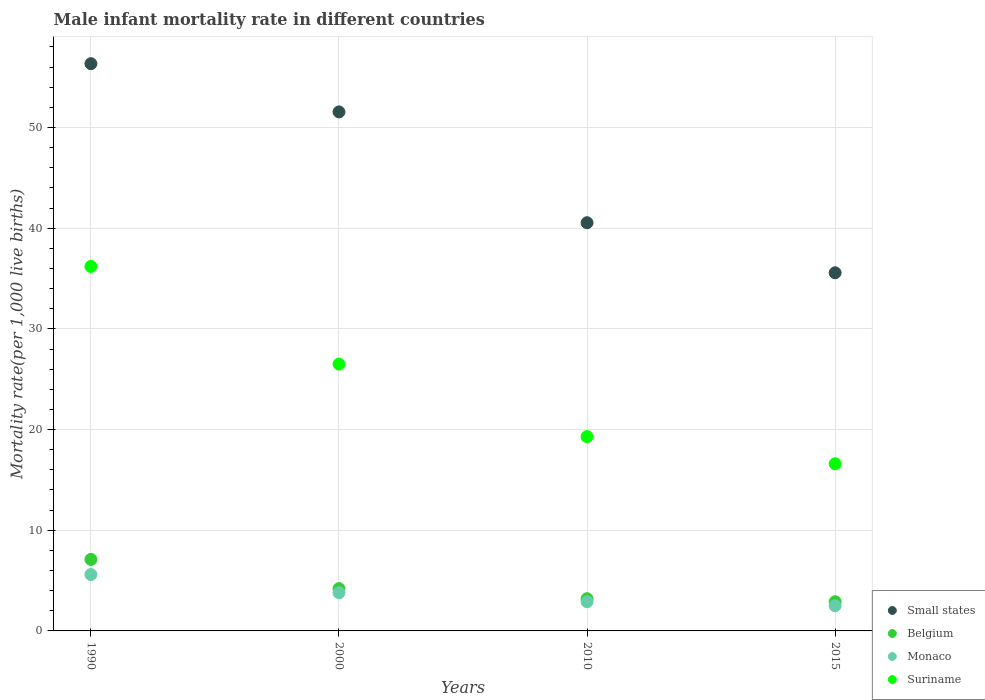How many different coloured dotlines are there?
Your answer should be compact. 4. What is the male infant mortality rate in Suriname in 2010?
Make the answer very short. 19.3. Across all years, what is the maximum male infant mortality rate in Small states?
Keep it short and to the point. 56.34. In which year was the male infant mortality rate in Monaco minimum?
Offer a terse response. 2015. What is the total male infant mortality rate in Suriname in the graph?
Your answer should be very brief. 98.6. What is the difference between the male infant mortality rate in Small states in 2000 and that in 2015?
Offer a terse response. 15.98. What is the difference between the male infant mortality rate in Suriname in 2000 and the male infant mortality rate in Belgium in 2010?
Your answer should be very brief. 23.3. What is the average male infant mortality rate in Belgium per year?
Ensure brevity in your answer.  4.35. In the year 2010, what is the difference between the male infant mortality rate in Suriname and male infant mortality rate in Monaco?
Give a very brief answer. 16.4. In how many years, is the male infant mortality rate in Monaco greater than 50?
Make the answer very short. 0. What is the ratio of the male infant mortality rate in Small states in 1990 to that in 2010?
Make the answer very short. 1.39. What is the difference between the highest and the second highest male infant mortality rate in Monaco?
Your answer should be very brief. 1.8. What is the difference between the highest and the lowest male infant mortality rate in Small states?
Ensure brevity in your answer.  20.77. Is it the case that in every year, the sum of the male infant mortality rate in Suriname and male infant mortality rate in Monaco  is greater than the sum of male infant mortality rate in Belgium and male infant mortality rate in Small states?
Your answer should be compact. Yes. Is it the case that in every year, the sum of the male infant mortality rate in Suriname and male infant mortality rate in Belgium  is greater than the male infant mortality rate in Monaco?
Offer a terse response. Yes. Is the male infant mortality rate in Belgium strictly greater than the male infant mortality rate in Small states over the years?
Offer a very short reply. No. How many dotlines are there?
Keep it short and to the point. 4. Are the values on the major ticks of Y-axis written in scientific E-notation?
Make the answer very short. No. Does the graph contain any zero values?
Your answer should be very brief. No. Does the graph contain grids?
Provide a succinct answer. Yes. Where does the legend appear in the graph?
Offer a very short reply. Bottom right. How many legend labels are there?
Keep it short and to the point. 4. What is the title of the graph?
Your answer should be compact. Male infant mortality rate in different countries. What is the label or title of the X-axis?
Keep it short and to the point. Years. What is the label or title of the Y-axis?
Provide a succinct answer. Mortality rate(per 1,0 live births). What is the Mortality rate(per 1,000 live births) in Small states in 1990?
Offer a very short reply. 56.34. What is the Mortality rate(per 1,000 live births) of Suriname in 1990?
Your response must be concise. 36.2. What is the Mortality rate(per 1,000 live births) in Small states in 2000?
Your response must be concise. 51.55. What is the Mortality rate(per 1,000 live births) of Belgium in 2000?
Keep it short and to the point. 4.2. What is the Mortality rate(per 1,000 live births) of Monaco in 2000?
Give a very brief answer. 3.8. What is the Mortality rate(per 1,000 live births) in Suriname in 2000?
Your answer should be very brief. 26.5. What is the Mortality rate(per 1,000 live births) of Small states in 2010?
Keep it short and to the point. 40.54. What is the Mortality rate(per 1,000 live births) in Belgium in 2010?
Your answer should be very brief. 3.2. What is the Mortality rate(per 1,000 live births) in Monaco in 2010?
Give a very brief answer. 2.9. What is the Mortality rate(per 1,000 live births) of Suriname in 2010?
Offer a very short reply. 19.3. What is the Mortality rate(per 1,000 live births) of Small states in 2015?
Ensure brevity in your answer.  35.57. What is the Mortality rate(per 1,000 live births) of Monaco in 2015?
Ensure brevity in your answer.  2.5. What is the Mortality rate(per 1,000 live births) in Suriname in 2015?
Ensure brevity in your answer.  16.6. Across all years, what is the maximum Mortality rate(per 1,000 live births) in Small states?
Provide a succinct answer. 56.34. Across all years, what is the maximum Mortality rate(per 1,000 live births) in Monaco?
Offer a very short reply. 5.6. Across all years, what is the maximum Mortality rate(per 1,000 live births) of Suriname?
Provide a short and direct response. 36.2. Across all years, what is the minimum Mortality rate(per 1,000 live births) of Small states?
Offer a very short reply. 35.57. Across all years, what is the minimum Mortality rate(per 1,000 live births) in Monaco?
Provide a short and direct response. 2.5. What is the total Mortality rate(per 1,000 live births) of Small states in the graph?
Your answer should be compact. 184. What is the total Mortality rate(per 1,000 live births) in Suriname in the graph?
Ensure brevity in your answer.  98.6. What is the difference between the Mortality rate(per 1,000 live births) of Small states in 1990 and that in 2000?
Your answer should be very brief. 4.79. What is the difference between the Mortality rate(per 1,000 live births) in Suriname in 1990 and that in 2000?
Make the answer very short. 9.7. What is the difference between the Mortality rate(per 1,000 live births) of Small states in 1990 and that in 2010?
Provide a short and direct response. 15.8. What is the difference between the Mortality rate(per 1,000 live births) of Belgium in 1990 and that in 2010?
Provide a succinct answer. 3.9. What is the difference between the Mortality rate(per 1,000 live births) in Small states in 1990 and that in 2015?
Your answer should be very brief. 20.77. What is the difference between the Mortality rate(per 1,000 live births) of Belgium in 1990 and that in 2015?
Provide a short and direct response. 4.2. What is the difference between the Mortality rate(per 1,000 live births) of Monaco in 1990 and that in 2015?
Keep it short and to the point. 3.1. What is the difference between the Mortality rate(per 1,000 live births) in Suriname in 1990 and that in 2015?
Give a very brief answer. 19.6. What is the difference between the Mortality rate(per 1,000 live births) in Small states in 2000 and that in 2010?
Your answer should be very brief. 11.01. What is the difference between the Mortality rate(per 1,000 live births) of Small states in 2000 and that in 2015?
Make the answer very short. 15.98. What is the difference between the Mortality rate(per 1,000 live births) in Suriname in 2000 and that in 2015?
Offer a very short reply. 9.9. What is the difference between the Mortality rate(per 1,000 live births) of Small states in 2010 and that in 2015?
Keep it short and to the point. 4.97. What is the difference between the Mortality rate(per 1,000 live births) in Belgium in 2010 and that in 2015?
Provide a succinct answer. 0.3. What is the difference between the Mortality rate(per 1,000 live births) in Small states in 1990 and the Mortality rate(per 1,000 live births) in Belgium in 2000?
Make the answer very short. 52.14. What is the difference between the Mortality rate(per 1,000 live births) in Small states in 1990 and the Mortality rate(per 1,000 live births) in Monaco in 2000?
Your response must be concise. 52.54. What is the difference between the Mortality rate(per 1,000 live births) in Small states in 1990 and the Mortality rate(per 1,000 live births) in Suriname in 2000?
Your answer should be very brief. 29.84. What is the difference between the Mortality rate(per 1,000 live births) of Belgium in 1990 and the Mortality rate(per 1,000 live births) of Monaco in 2000?
Provide a short and direct response. 3.3. What is the difference between the Mortality rate(per 1,000 live births) of Belgium in 1990 and the Mortality rate(per 1,000 live births) of Suriname in 2000?
Provide a succinct answer. -19.4. What is the difference between the Mortality rate(per 1,000 live births) in Monaco in 1990 and the Mortality rate(per 1,000 live births) in Suriname in 2000?
Keep it short and to the point. -20.9. What is the difference between the Mortality rate(per 1,000 live births) in Small states in 1990 and the Mortality rate(per 1,000 live births) in Belgium in 2010?
Offer a terse response. 53.14. What is the difference between the Mortality rate(per 1,000 live births) in Small states in 1990 and the Mortality rate(per 1,000 live births) in Monaco in 2010?
Offer a very short reply. 53.44. What is the difference between the Mortality rate(per 1,000 live births) in Small states in 1990 and the Mortality rate(per 1,000 live births) in Suriname in 2010?
Offer a very short reply. 37.04. What is the difference between the Mortality rate(per 1,000 live births) in Belgium in 1990 and the Mortality rate(per 1,000 live births) in Monaco in 2010?
Make the answer very short. 4.2. What is the difference between the Mortality rate(per 1,000 live births) in Belgium in 1990 and the Mortality rate(per 1,000 live births) in Suriname in 2010?
Make the answer very short. -12.2. What is the difference between the Mortality rate(per 1,000 live births) of Monaco in 1990 and the Mortality rate(per 1,000 live births) of Suriname in 2010?
Your answer should be very brief. -13.7. What is the difference between the Mortality rate(per 1,000 live births) of Small states in 1990 and the Mortality rate(per 1,000 live births) of Belgium in 2015?
Offer a very short reply. 53.44. What is the difference between the Mortality rate(per 1,000 live births) in Small states in 1990 and the Mortality rate(per 1,000 live births) in Monaco in 2015?
Provide a succinct answer. 53.84. What is the difference between the Mortality rate(per 1,000 live births) of Small states in 1990 and the Mortality rate(per 1,000 live births) of Suriname in 2015?
Your response must be concise. 39.74. What is the difference between the Mortality rate(per 1,000 live births) in Belgium in 1990 and the Mortality rate(per 1,000 live births) in Monaco in 2015?
Your answer should be compact. 4.6. What is the difference between the Mortality rate(per 1,000 live births) of Belgium in 1990 and the Mortality rate(per 1,000 live births) of Suriname in 2015?
Ensure brevity in your answer.  -9.5. What is the difference between the Mortality rate(per 1,000 live births) of Small states in 2000 and the Mortality rate(per 1,000 live births) of Belgium in 2010?
Your response must be concise. 48.35. What is the difference between the Mortality rate(per 1,000 live births) in Small states in 2000 and the Mortality rate(per 1,000 live births) in Monaco in 2010?
Keep it short and to the point. 48.65. What is the difference between the Mortality rate(per 1,000 live births) of Small states in 2000 and the Mortality rate(per 1,000 live births) of Suriname in 2010?
Your answer should be very brief. 32.25. What is the difference between the Mortality rate(per 1,000 live births) of Belgium in 2000 and the Mortality rate(per 1,000 live births) of Monaco in 2010?
Your response must be concise. 1.3. What is the difference between the Mortality rate(per 1,000 live births) in Belgium in 2000 and the Mortality rate(per 1,000 live births) in Suriname in 2010?
Provide a short and direct response. -15.1. What is the difference between the Mortality rate(per 1,000 live births) of Monaco in 2000 and the Mortality rate(per 1,000 live births) of Suriname in 2010?
Make the answer very short. -15.5. What is the difference between the Mortality rate(per 1,000 live births) of Small states in 2000 and the Mortality rate(per 1,000 live births) of Belgium in 2015?
Ensure brevity in your answer.  48.65. What is the difference between the Mortality rate(per 1,000 live births) of Small states in 2000 and the Mortality rate(per 1,000 live births) of Monaco in 2015?
Your answer should be very brief. 49.05. What is the difference between the Mortality rate(per 1,000 live births) of Small states in 2000 and the Mortality rate(per 1,000 live births) of Suriname in 2015?
Offer a very short reply. 34.95. What is the difference between the Mortality rate(per 1,000 live births) of Belgium in 2000 and the Mortality rate(per 1,000 live births) of Monaco in 2015?
Make the answer very short. 1.7. What is the difference between the Mortality rate(per 1,000 live births) in Monaco in 2000 and the Mortality rate(per 1,000 live births) in Suriname in 2015?
Ensure brevity in your answer.  -12.8. What is the difference between the Mortality rate(per 1,000 live births) in Small states in 2010 and the Mortality rate(per 1,000 live births) in Belgium in 2015?
Give a very brief answer. 37.64. What is the difference between the Mortality rate(per 1,000 live births) in Small states in 2010 and the Mortality rate(per 1,000 live births) in Monaco in 2015?
Your answer should be compact. 38.04. What is the difference between the Mortality rate(per 1,000 live births) of Small states in 2010 and the Mortality rate(per 1,000 live births) of Suriname in 2015?
Give a very brief answer. 23.94. What is the difference between the Mortality rate(per 1,000 live births) of Belgium in 2010 and the Mortality rate(per 1,000 live births) of Monaco in 2015?
Keep it short and to the point. 0.7. What is the difference between the Mortality rate(per 1,000 live births) of Monaco in 2010 and the Mortality rate(per 1,000 live births) of Suriname in 2015?
Make the answer very short. -13.7. What is the average Mortality rate(per 1,000 live births) in Small states per year?
Your answer should be very brief. 46. What is the average Mortality rate(per 1,000 live births) in Belgium per year?
Provide a short and direct response. 4.35. What is the average Mortality rate(per 1,000 live births) of Monaco per year?
Keep it short and to the point. 3.7. What is the average Mortality rate(per 1,000 live births) of Suriname per year?
Ensure brevity in your answer.  24.65. In the year 1990, what is the difference between the Mortality rate(per 1,000 live births) of Small states and Mortality rate(per 1,000 live births) of Belgium?
Make the answer very short. 49.24. In the year 1990, what is the difference between the Mortality rate(per 1,000 live births) in Small states and Mortality rate(per 1,000 live births) in Monaco?
Provide a short and direct response. 50.74. In the year 1990, what is the difference between the Mortality rate(per 1,000 live births) of Small states and Mortality rate(per 1,000 live births) of Suriname?
Provide a short and direct response. 20.14. In the year 1990, what is the difference between the Mortality rate(per 1,000 live births) of Belgium and Mortality rate(per 1,000 live births) of Monaco?
Your response must be concise. 1.5. In the year 1990, what is the difference between the Mortality rate(per 1,000 live births) in Belgium and Mortality rate(per 1,000 live births) in Suriname?
Offer a terse response. -29.1. In the year 1990, what is the difference between the Mortality rate(per 1,000 live births) in Monaco and Mortality rate(per 1,000 live births) in Suriname?
Your response must be concise. -30.6. In the year 2000, what is the difference between the Mortality rate(per 1,000 live births) in Small states and Mortality rate(per 1,000 live births) in Belgium?
Provide a short and direct response. 47.35. In the year 2000, what is the difference between the Mortality rate(per 1,000 live births) of Small states and Mortality rate(per 1,000 live births) of Monaco?
Offer a very short reply. 47.75. In the year 2000, what is the difference between the Mortality rate(per 1,000 live births) in Small states and Mortality rate(per 1,000 live births) in Suriname?
Provide a short and direct response. 25.05. In the year 2000, what is the difference between the Mortality rate(per 1,000 live births) in Belgium and Mortality rate(per 1,000 live births) in Suriname?
Make the answer very short. -22.3. In the year 2000, what is the difference between the Mortality rate(per 1,000 live births) of Monaco and Mortality rate(per 1,000 live births) of Suriname?
Give a very brief answer. -22.7. In the year 2010, what is the difference between the Mortality rate(per 1,000 live births) of Small states and Mortality rate(per 1,000 live births) of Belgium?
Give a very brief answer. 37.34. In the year 2010, what is the difference between the Mortality rate(per 1,000 live births) of Small states and Mortality rate(per 1,000 live births) of Monaco?
Provide a short and direct response. 37.64. In the year 2010, what is the difference between the Mortality rate(per 1,000 live births) of Small states and Mortality rate(per 1,000 live births) of Suriname?
Your response must be concise. 21.24. In the year 2010, what is the difference between the Mortality rate(per 1,000 live births) in Belgium and Mortality rate(per 1,000 live births) in Suriname?
Provide a short and direct response. -16.1. In the year 2010, what is the difference between the Mortality rate(per 1,000 live births) of Monaco and Mortality rate(per 1,000 live births) of Suriname?
Make the answer very short. -16.4. In the year 2015, what is the difference between the Mortality rate(per 1,000 live births) of Small states and Mortality rate(per 1,000 live births) of Belgium?
Your answer should be very brief. 32.67. In the year 2015, what is the difference between the Mortality rate(per 1,000 live births) of Small states and Mortality rate(per 1,000 live births) of Monaco?
Keep it short and to the point. 33.07. In the year 2015, what is the difference between the Mortality rate(per 1,000 live births) in Small states and Mortality rate(per 1,000 live births) in Suriname?
Keep it short and to the point. 18.97. In the year 2015, what is the difference between the Mortality rate(per 1,000 live births) in Belgium and Mortality rate(per 1,000 live births) in Monaco?
Provide a short and direct response. 0.4. In the year 2015, what is the difference between the Mortality rate(per 1,000 live births) in Belgium and Mortality rate(per 1,000 live births) in Suriname?
Give a very brief answer. -13.7. In the year 2015, what is the difference between the Mortality rate(per 1,000 live births) of Monaco and Mortality rate(per 1,000 live births) of Suriname?
Make the answer very short. -14.1. What is the ratio of the Mortality rate(per 1,000 live births) of Small states in 1990 to that in 2000?
Your answer should be very brief. 1.09. What is the ratio of the Mortality rate(per 1,000 live births) of Belgium in 1990 to that in 2000?
Offer a terse response. 1.69. What is the ratio of the Mortality rate(per 1,000 live births) of Monaco in 1990 to that in 2000?
Keep it short and to the point. 1.47. What is the ratio of the Mortality rate(per 1,000 live births) in Suriname in 1990 to that in 2000?
Your answer should be compact. 1.37. What is the ratio of the Mortality rate(per 1,000 live births) in Small states in 1990 to that in 2010?
Provide a short and direct response. 1.39. What is the ratio of the Mortality rate(per 1,000 live births) in Belgium in 1990 to that in 2010?
Ensure brevity in your answer.  2.22. What is the ratio of the Mortality rate(per 1,000 live births) in Monaco in 1990 to that in 2010?
Give a very brief answer. 1.93. What is the ratio of the Mortality rate(per 1,000 live births) in Suriname in 1990 to that in 2010?
Offer a terse response. 1.88. What is the ratio of the Mortality rate(per 1,000 live births) of Small states in 1990 to that in 2015?
Your answer should be very brief. 1.58. What is the ratio of the Mortality rate(per 1,000 live births) of Belgium in 1990 to that in 2015?
Your answer should be compact. 2.45. What is the ratio of the Mortality rate(per 1,000 live births) of Monaco in 1990 to that in 2015?
Offer a very short reply. 2.24. What is the ratio of the Mortality rate(per 1,000 live births) in Suriname in 1990 to that in 2015?
Give a very brief answer. 2.18. What is the ratio of the Mortality rate(per 1,000 live births) of Small states in 2000 to that in 2010?
Make the answer very short. 1.27. What is the ratio of the Mortality rate(per 1,000 live births) in Belgium in 2000 to that in 2010?
Provide a succinct answer. 1.31. What is the ratio of the Mortality rate(per 1,000 live births) of Monaco in 2000 to that in 2010?
Your answer should be compact. 1.31. What is the ratio of the Mortality rate(per 1,000 live births) in Suriname in 2000 to that in 2010?
Ensure brevity in your answer.  1.37. What is the ratio of the Mortality rate(per 1,000 live births) in Small states in 2000 to that in 2015?
Your answer should be compact. 1.45. What is the ratio of the Mortality rate(per 1,000 live births) of Belgium in 2000 to that in 2015?
Provide a short and direct response. 1.45. What is the ratio of the Mortality rate(per 1,000 live births) in Monaco in 2000 to that in 2015?
Your answer should be very brief. 1.52. What is the ratio of the Mortality rate(per 1,000 live births) of Suriname in 2000 to that in 2015?
Provide a succinct answer. 1.6. What is the ratio of the Mortality rate(per 1,000 live births) of Small states in 2010 to that in 2015?
Offer a terse response. 1.14. What is the ratio of the Mortality rate(per 1,000 live births) of Belgium in 2010 to that in 2015?
Your response must be concise. 1.1. What is the ratio of the Mortality rate(per 1,000 live births) of Monaco in 2010 to that in 2015?
Your answer should be very brief. 1.16. What is the ratio of the Mortality rate(per 1,000 live births) of Suriname in 2010 to that in 2015?
Your response must be concise. 1.16. What is the difference between the highest and the second highest Mortality rate(per 1,000 live births) in Small states?
Offer a very short reply. 4.79. What is the difference between the highest and the second highest Mortality rate(per 1,000 live births) of Suriname?
Offer a terse response. 9.7. What is the difference between the highest and the lowest Mortality rate(per 1,000 live births) in Small states?
Your answer should be compact. 20.77. What is the difference between the highest and the lowest Mortality rate(per 1,000 live births) in Suriname?
Provide a succinct answer. 19.6. 